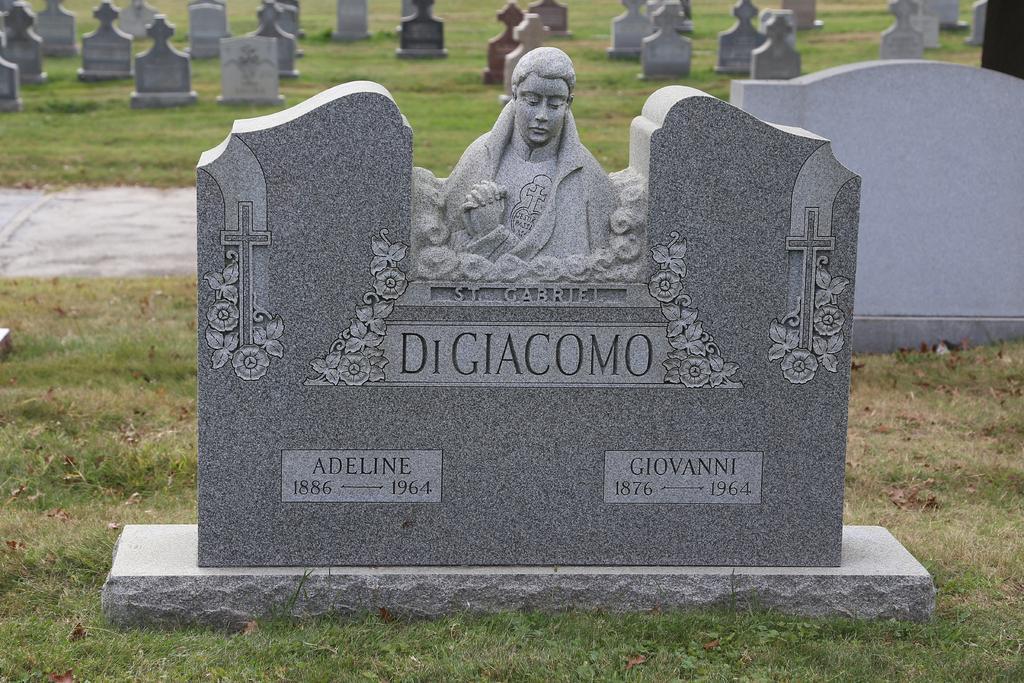Could you give a brief overview of what you see in this image? In this image we can see some graves, there is a sculpture, cross symbols, and some texts on a grave, also we can see some grass. 